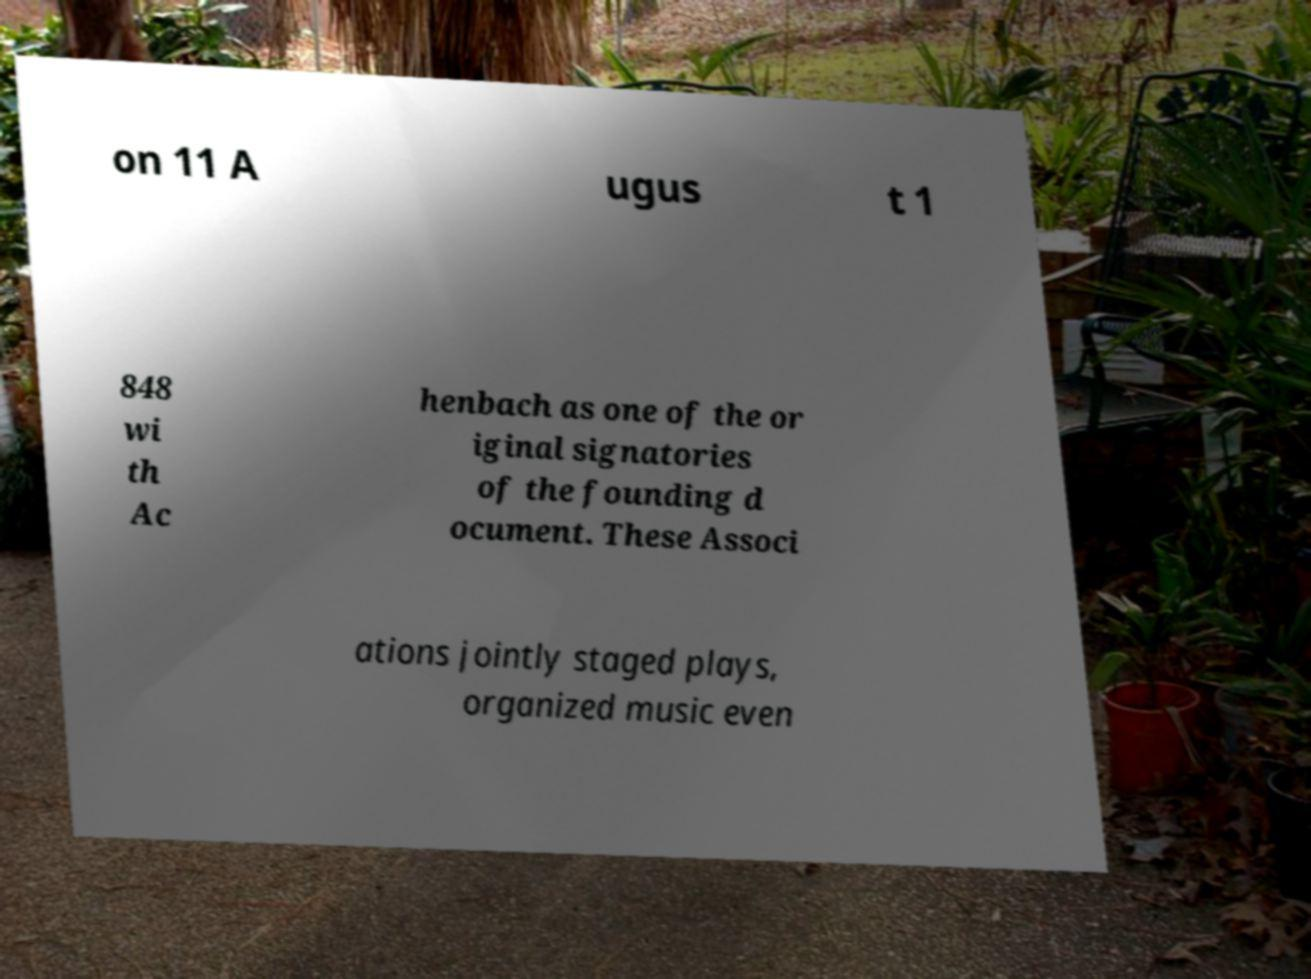Please identify and transcribe the text found in this image. on 11 A ugus t 1 848 wi th Ac henbach as one of the or iginal signatories of the founding d ocument. These Associ ations jointly staged plays, organized music even 